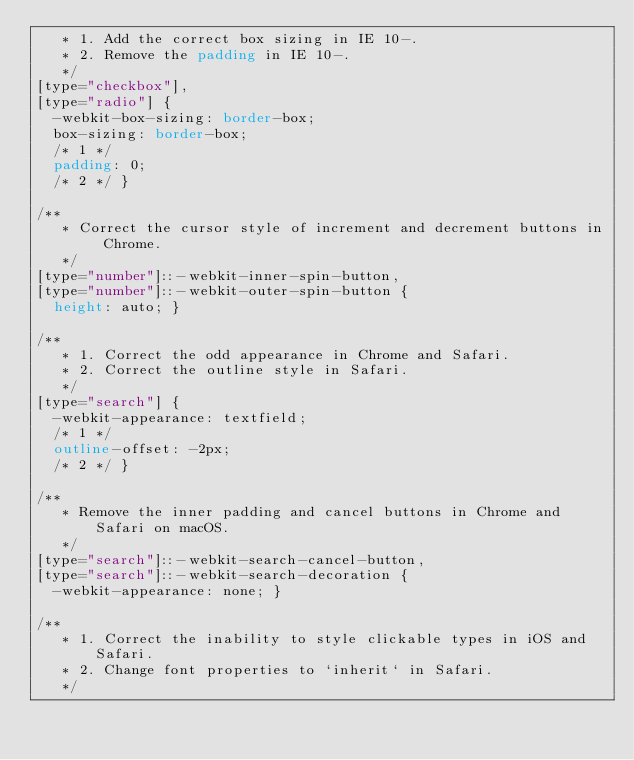<code> <loc_0><loc_0><loc_500><loc_500><_CSS_>   * 1. Add the correct box sizing in IE 10-.
   * 2. Remove the padding in IE 10-.
   */
[type="checkbox"],
[type="radio"] {
  -webkit-box-sizing: border-box;
  box-sizing: border-box;
  /* 1 */
  padding: 0;
  /* 2 */ }

/**
   * Correct the cursor style of increment and decrement buttons in Chrome.
   */
[type="number"]::-webkit-inner-spin-button,
[type="number"]::-webkit-outer-spin-button {
  height: auto; }

/**
   * 1. Correct the odd appearance in Chrome and Safari.
   * 2. Correct the outline style in Safari.
   */
[type="search"] {
  -webkit-appearance: textfield;
  /* 1 */
  outline-offset: -2px;
  /* 2 */ }

/**
   * Remove the inner padding and cancel buttons in Chrome and Safari on macOS.
   */
[type="search"]::-webkit-search-cancel-button,
[type="search"]::-webkit-search-decoration {
  -webkit-appearance: none; }

/**
   * 1. Correct the inability to style clickable types in iOS and Safari.
   * 2. Change font properties to `inherit` in Safari.
   */</code> 